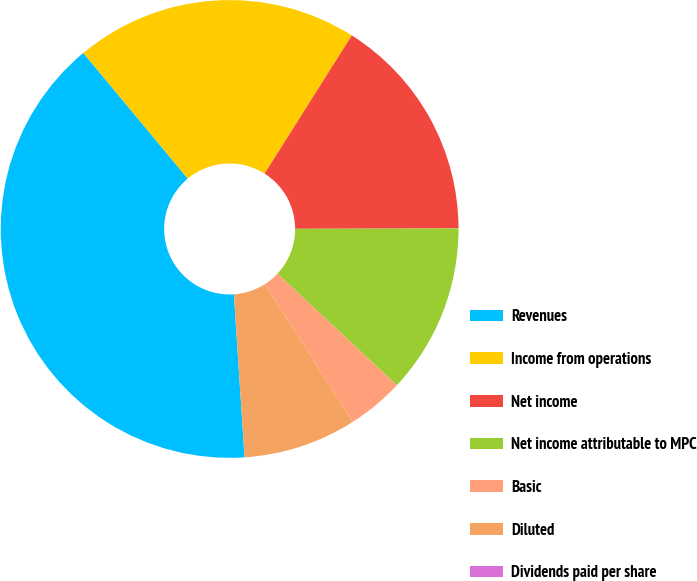Convert chart. <chart><loc_0><loc_0><loc_500><loc_500><pie_chart><fcel>Revenues<fcel>Income from operations<fcel>Net income<fcel>Net income attributable to MPC<fcel>Basic<fcel>Diluted<fcel>Dividends paid per share<nl><fcel>40.0%<fcel>20.0%<fcel>16.0%<fcel>12.0%<fcel>4.0%<fcel>8.0%<fcel>0.0%<nl></chart> 